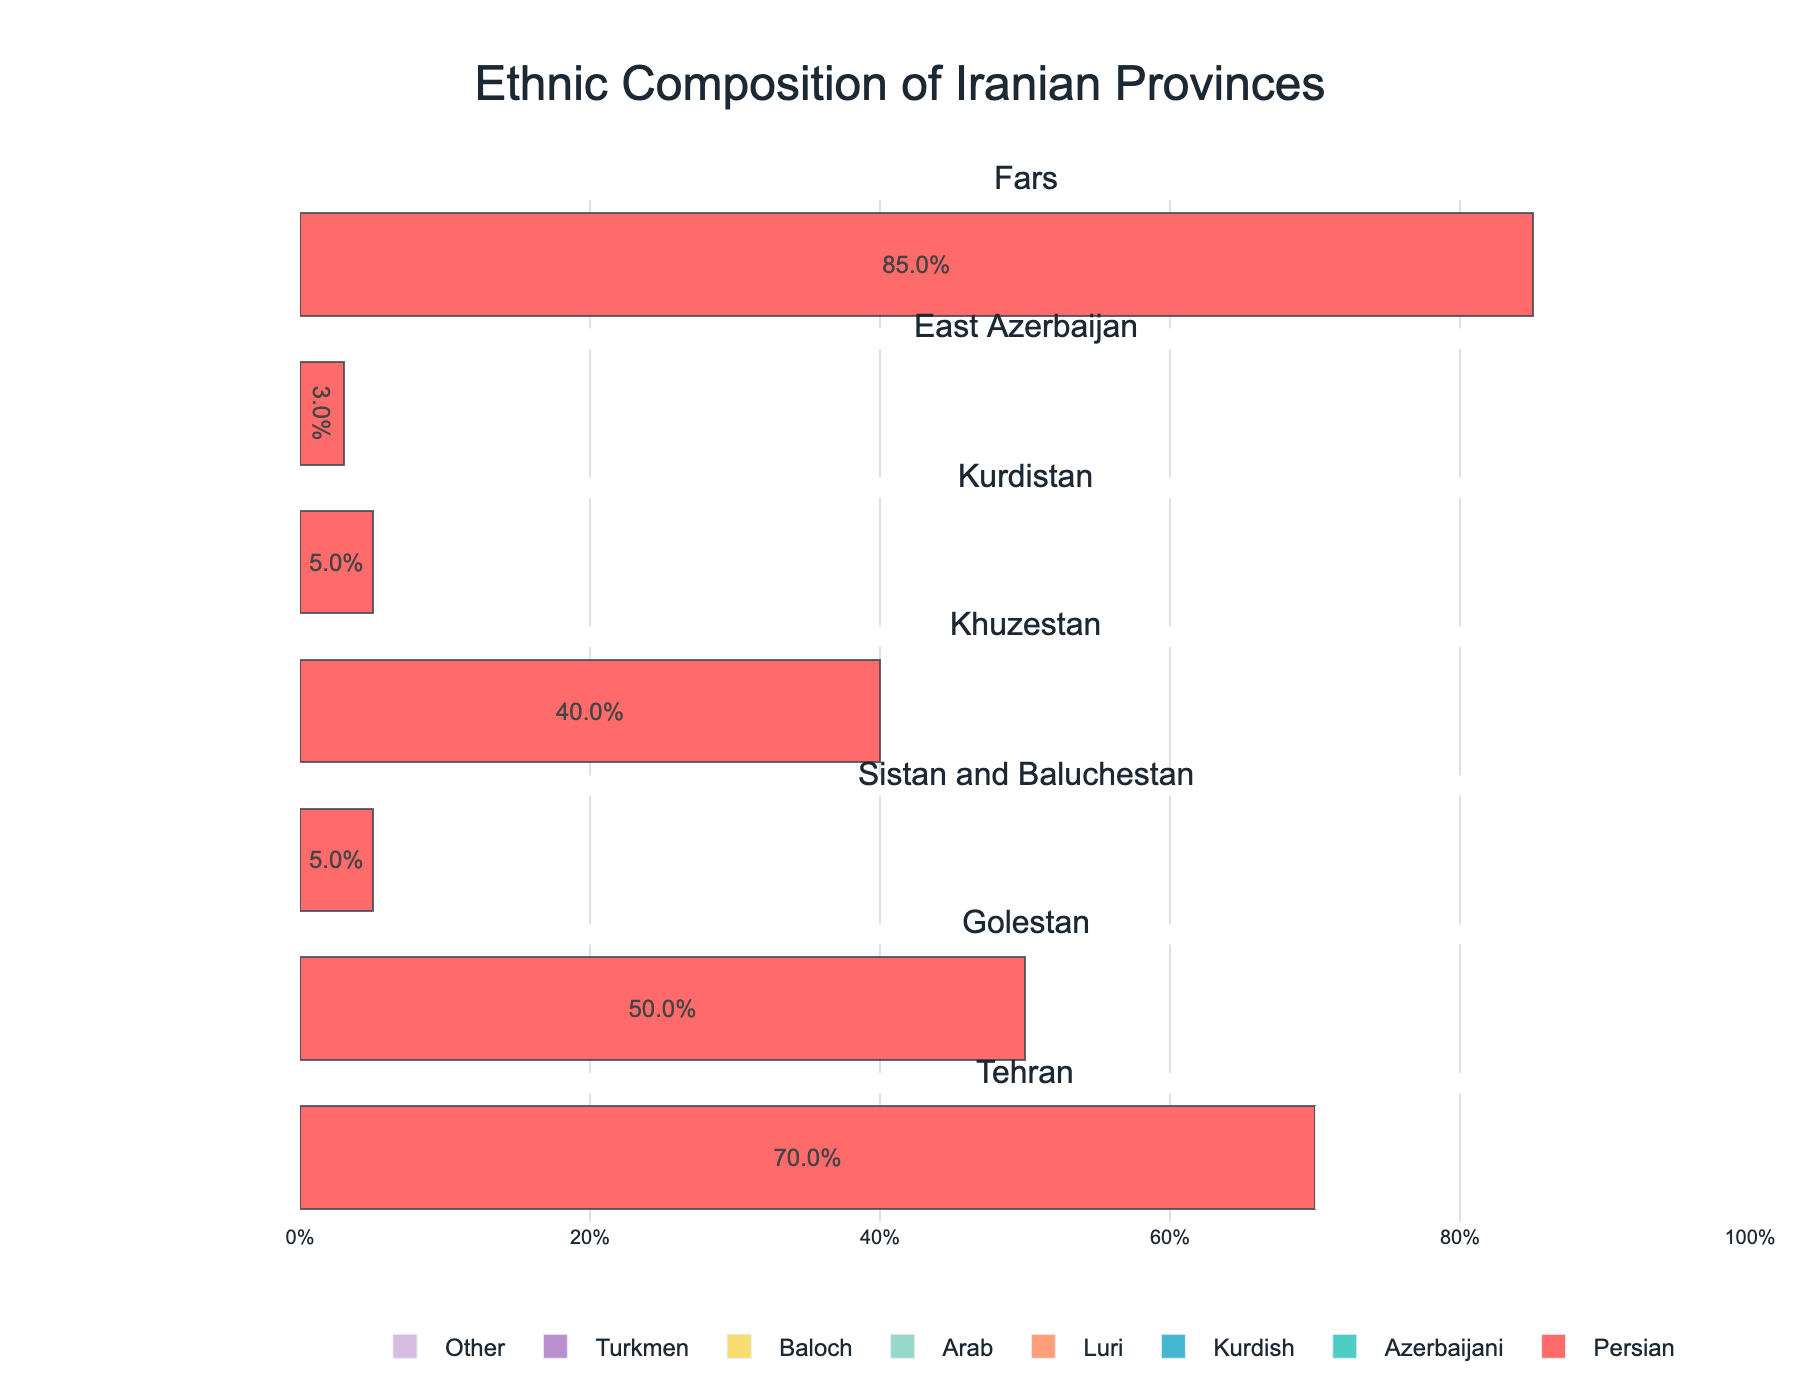Who has the highest percentage in Khuzestan province? To find the ethnic group with the highest percentage in Khuzestan province, look at the bars for Khuzestan. The largest bar corresponds to the Arab ethnic group, which occupies 50% of the population.
Answer: Arab What is the title of the figure? The title of the figure is centered at the top of the plot. It reads "Ethnic Composition of Iranian Provinces".
Answer: Ethnic Composition of Iranian Provinces How many ethnic groups make up Tehran province, and what are they? In the subplot for Tehran, count the number of distinct colored bars. There are seven different colors, each representing a different ethnic group. These groups are Persian, Azerbaijani, Kurdish, Luri, Arab, Baloch, and Turkmen.
Answer: 7; Persian, Azerbaijani, Kurdish, Luri, Arab, Baloch, Turkmen Compare the percentage of Azerbaijani in East Azerbaijan with the percentage of Persian in the same province. In East Azerbaijan, find the corresponding bars for Azerbaijani and Persian. Azerbaijani is at 95%, and Persian is at 3%. Therefore, Azerbaijani has a much higher percentage than Persian in East Azerbaijan.
Answer: Azerbaijani: 95%, Persian: 3% Which ethnic group has the second highest representation in Tehran? Look at the subplot for Tehran and identify the ethnic group with the second-largest bar. The largest is Persian (70%), followed by Azerbaijani (15%).
Answer: Azerbaijani What is the combined percentage of Kurdish and Luri in Tehran? Identify the percentages for Kurdish and Luri in Tehran from their respective bars. Kurdish is at 5%, and Luri is at 2%. Add these values together to get 7%.
Answer: 7% Which province has the highest percentage of Baloch population? Look for the subplots where the Baloch ethnicity is present. Sistan and Baluchestan has a Baloch population at 90%, which is the highest among all provinces.
Answer: Sistan and Baluchestan What percentage of the population in Fars is composed of ethnic groups other than Persian? In the subplot for Fars, find and sum the percentages of all ethnic groups except Persian. The values are: Azerbaijani (2%), Luri (8%), Arab (1%), and Other (4%). Summing these gives 2% + 8% + 1% + 4% = 15%.
Answer: 15% Compare the representation of Turkmen in Golestan and Tehran. Identify the Turkmen bars in Golestan and Tehran. In Golestan, Turkmen is at 45%. In Tehran, it’s at 1%. Thus, Turkmen have a significantly higher percentage in Golestan than in Tehran.
Answer: Golestan: 45%, Tehran: 1% Which province has the most diverse ethnic composition in terms of the number of different ethnic groups represented? Assess each subplot for the number of different colored bars representing ethnic groups. Tehran has the most ethnic groups represented with seven in total.
Answer: Tehran 